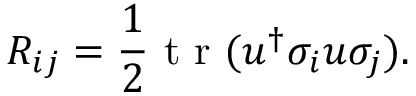Convert formula to latex. <formula><loc_0><loc_0><loc_500><loc_500>R _ { i j } = \frac { 1 } { 2 } { t r } ( u ^ { \dagger } \sigma _ { i } u \sigma _ { j } ) .</formula> 